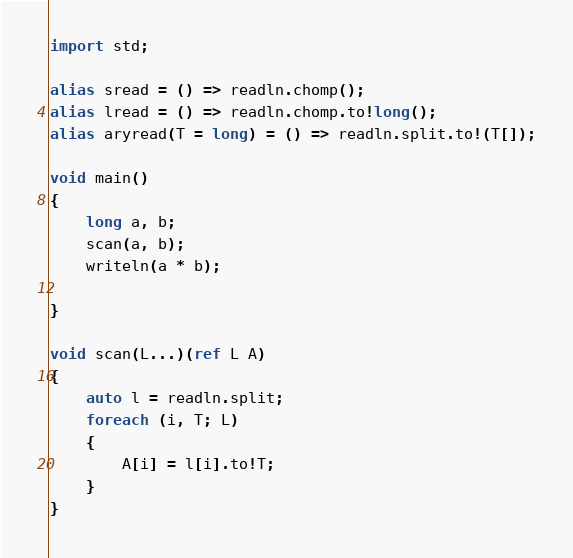<code> <loc_0><loc_0><loc_500><loc_500><_D_>import std;

alias sread = () => readln.chomp();
alias lread = () => readln.chomp.to!long();
alias aryread(T = long) = () => readln.split.to!(T[]);

void main()
{
    long a, b;
    scan(a, b);
    writeln(a * b);

}

void scan(L...)(ref L A)
{
    auto l = readln.split;
    foreach (i, T; L)
    {
        A[i] = l[i].to!T;
    }
}
</code> 